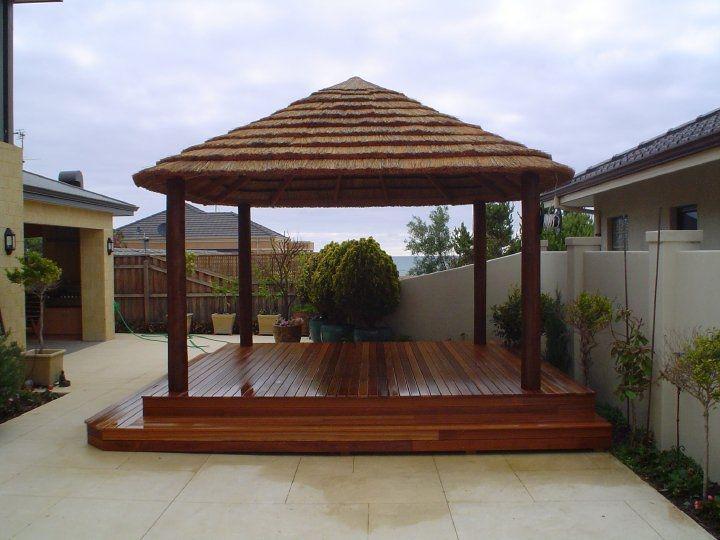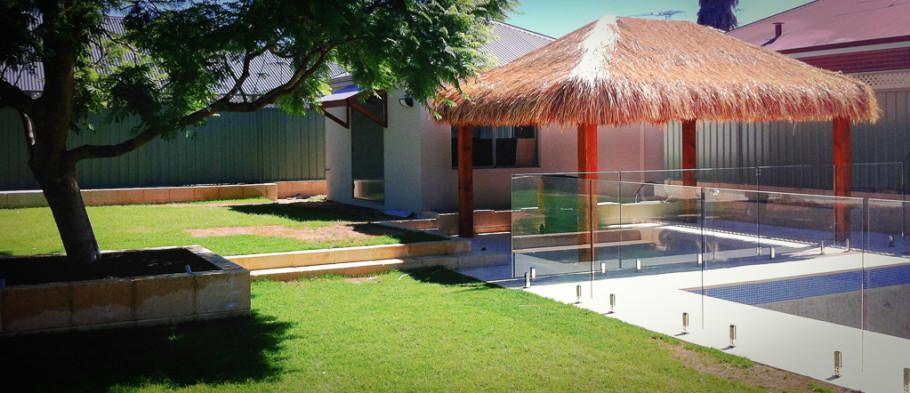The first image is the image on the left, the second image is the image on the right. For the images shown, is this caption "The right image shows a non-tiered thatch roof over an open-sided structure with square columns in the corners." true? Answer yes or no. Yes. The first image is the image on the left, the second image is the image on the right. Examine the images to the left and right. Is the description "Both of the structures are enclosed" accurate? Answer yes or no. No. 